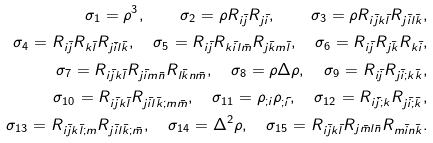<formula> <loc_0><loc_0><loc_500><loc_500>\sigma _ { 1 } = \rho ^ { 3 } , \quad \sigma _ { 2 } = \rho R _ { i \bar { j } } R _ { j \bar { i } } , \quad \sigma _ { 3 } = \rho R _ { i \bar { j } k \bar { l } } R _ { j \bar { i } l \bar { k } } , \\ \sigma _ { 4 } = R _ { i \bar { j } } R _ { k \bar { l } } R _ { j \bar { i } l \bar { k } } , \quad \sigma _ { 5 } = R _ { i \bar { j } } R _ { k \bar { i } l \bar { m } } R _ { j \bar { k } m \bar { l } } , \quad \sigma _ { 6 } = R _ { i \bar { j } } R _ { j \bar { k } } R _ { k \bar { i } } , \\ \sigma _ { 7 } = R _ { i \bar { j } k \bar { l } } R _ { j \bar { i } m \bar { n } } R _ { l \bar { k } n \bar { m } } , \quad \sigma _ { 8 } = \rho \Delta \rho , \quad \sigma _ { 9 } = R _ { i \bar { j } } R _ { j \bar { i } ; k \bar { k } } , \\ \sigma _ { 1 0 } = R _ { i \bar { j } k \bar { l } } R _ { j \bar { i } l \bar { k } ; m \bar { m } } , \quad \sigma _ { 1 1 } = \rho _ { ; i } \rho _ { ; \bar { i } } , \quad \sigma _ { 1 2 } = R _ { i \bar { j } ; k } R _ { j \bar { i } ; \bar { k } } , \\ \sigma _ { 1 3 } = R _ { i \bar { j } k \bar { l } ; m } R _ { j \bar { i } l \bar { k } ; \bar { m } } , \quad \sigma _ { 1 4 } = \Delta ^ { 2 } \rho , \quad \sigma _ { 1 5 } = R _ { i \bar { j } k \bar { l } } R _ { j \bar { m } l \bar { n } } R _ { m \bar { i } n \bar { k } } .</formula> 